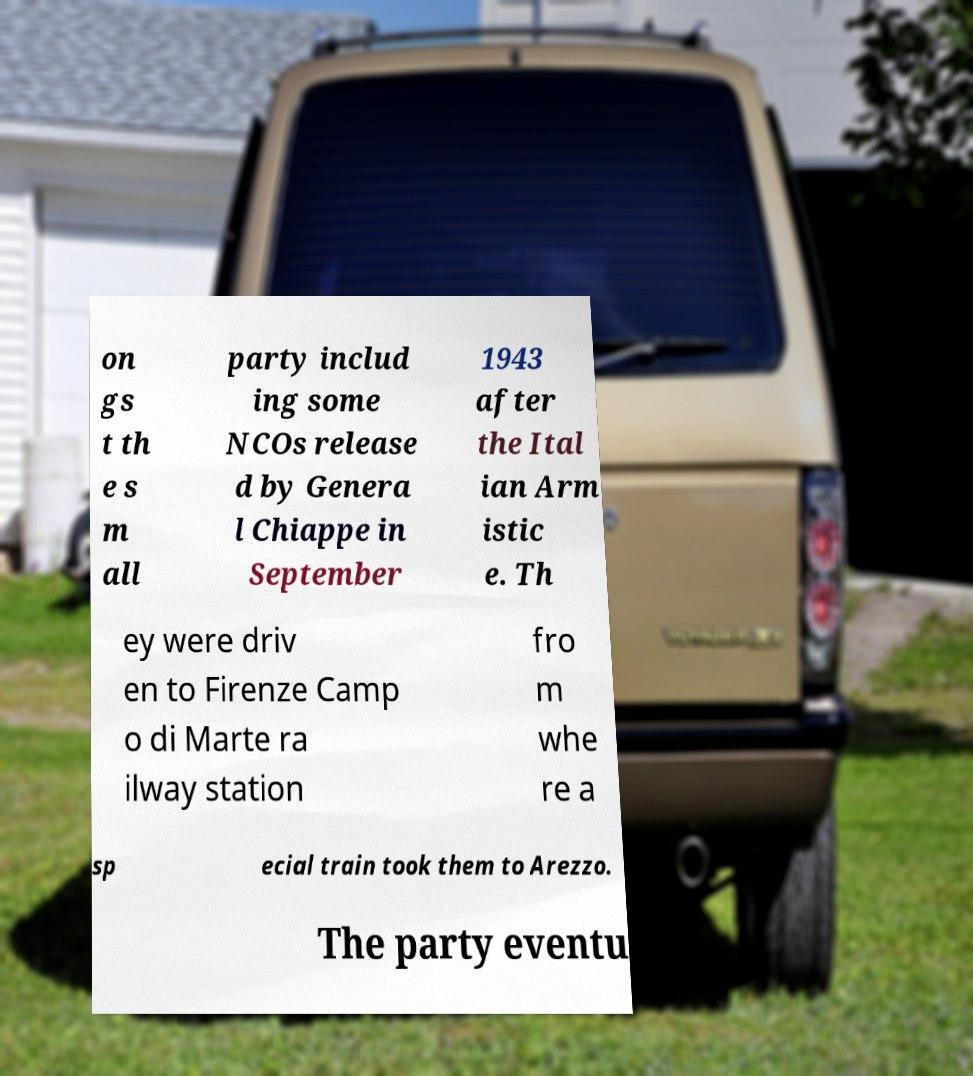For documentation purposes, I need the text within this image transcribed. Could you provide that? on gs t th e s m all party includ ing some NCOs release d by Genera l Chiappe in September 1943 after the Ital ian Arm istic e. Th ey were driv en to Firenze Camp o di Marte ra ilway station fro m whe re a sp ecial train took them to Arezzo. The party eventu 